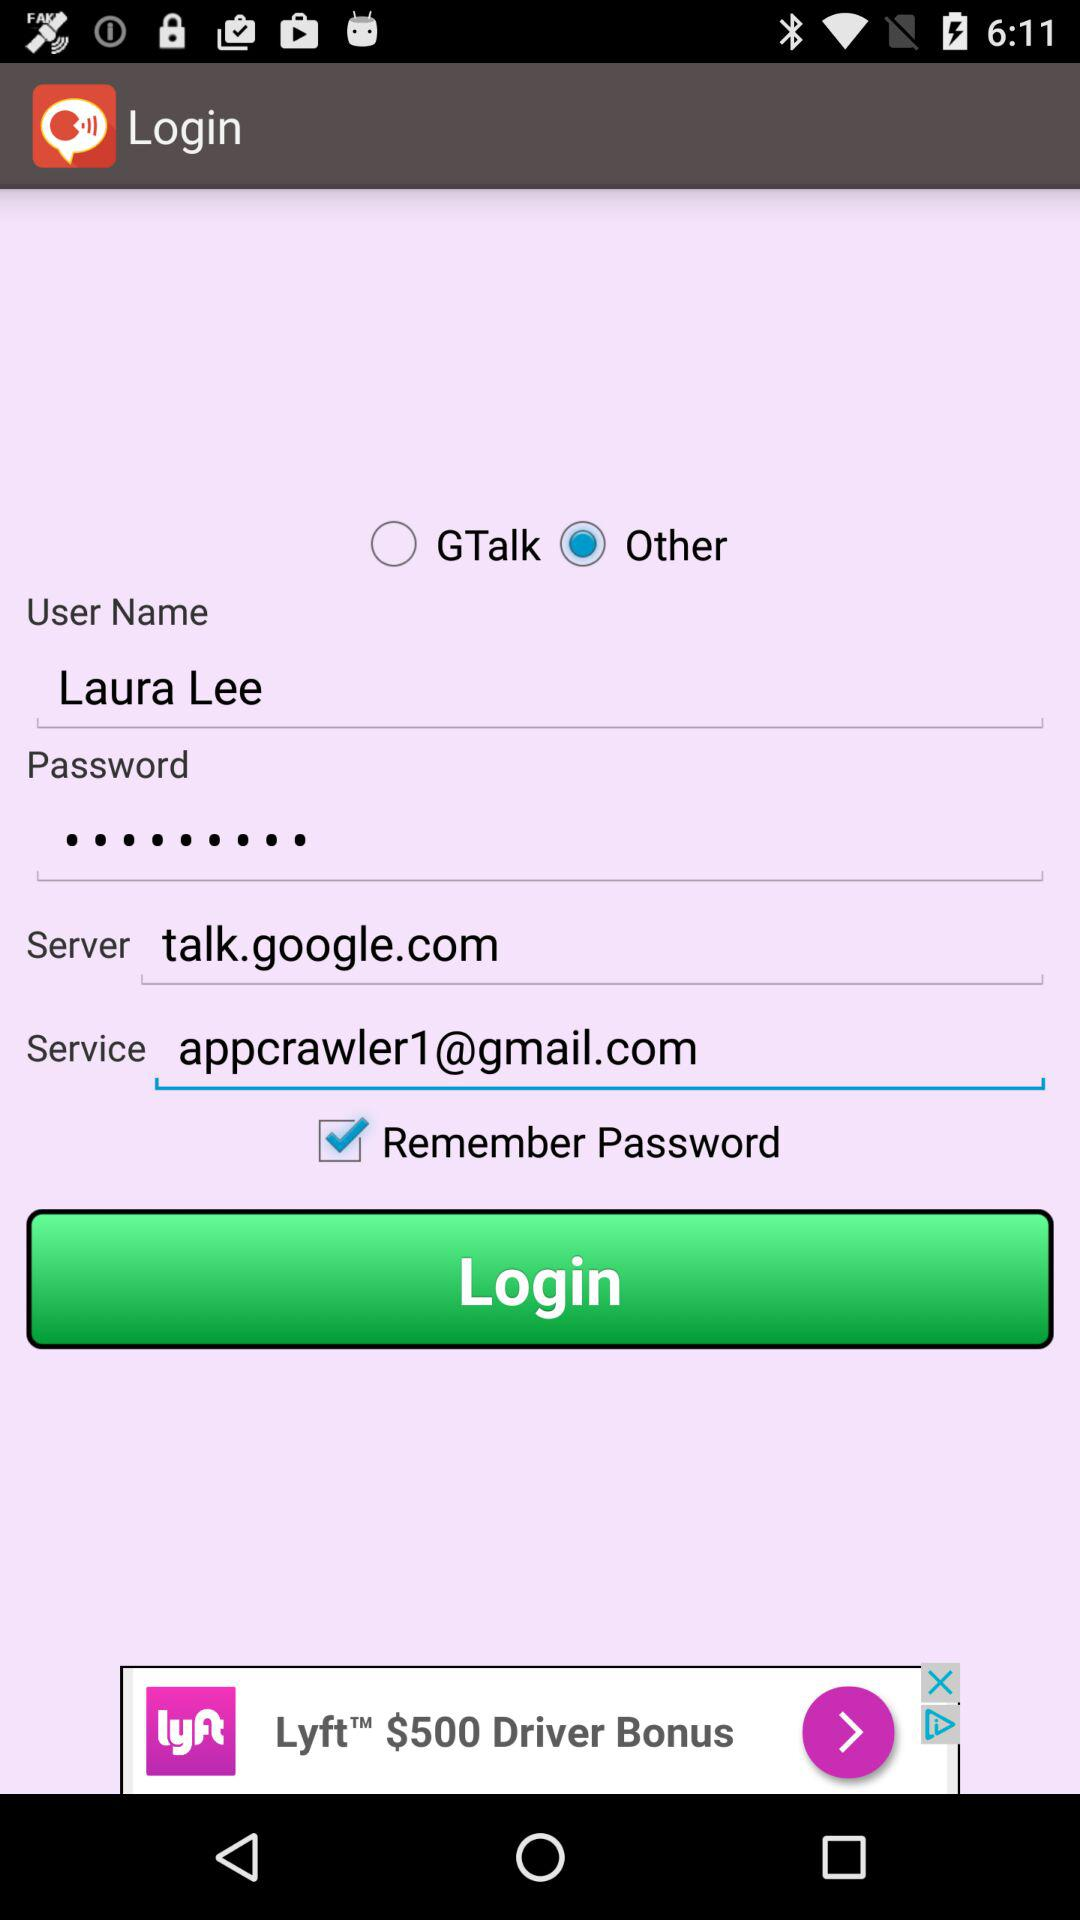What is the email address? The email address is appcrawler1@gmail.com. 